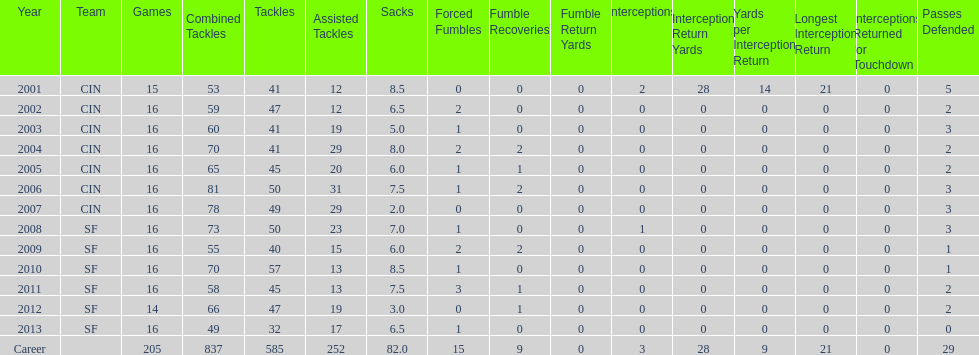What is the average number of tackles this player has had over his career? 45. 